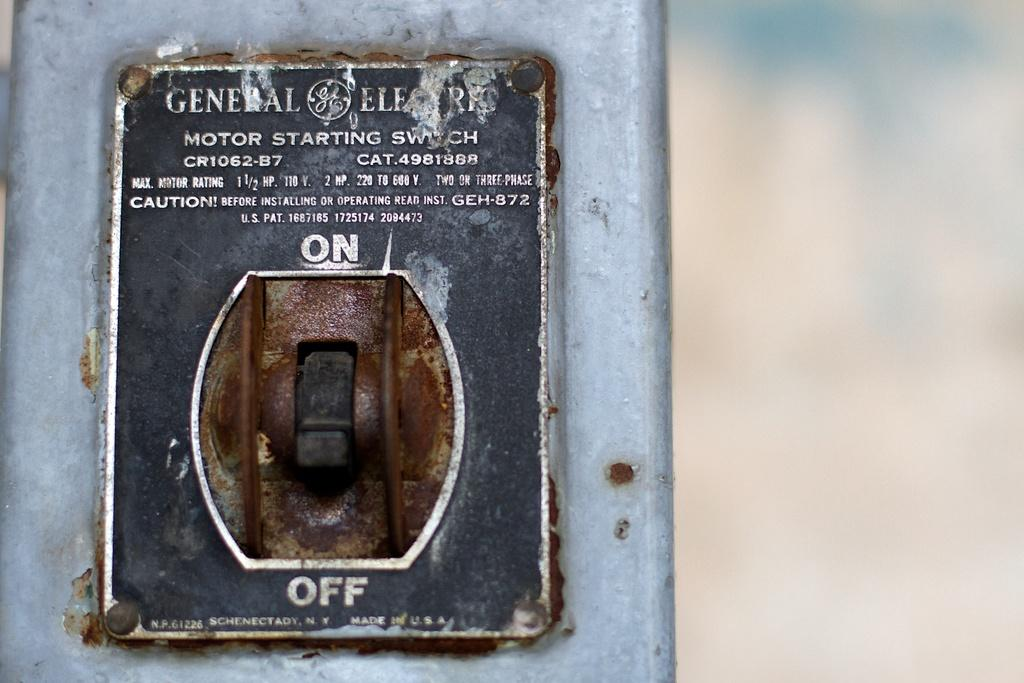Provide a one-sentence caption for the provided image. Well this very old switch pictured has been turned off. 